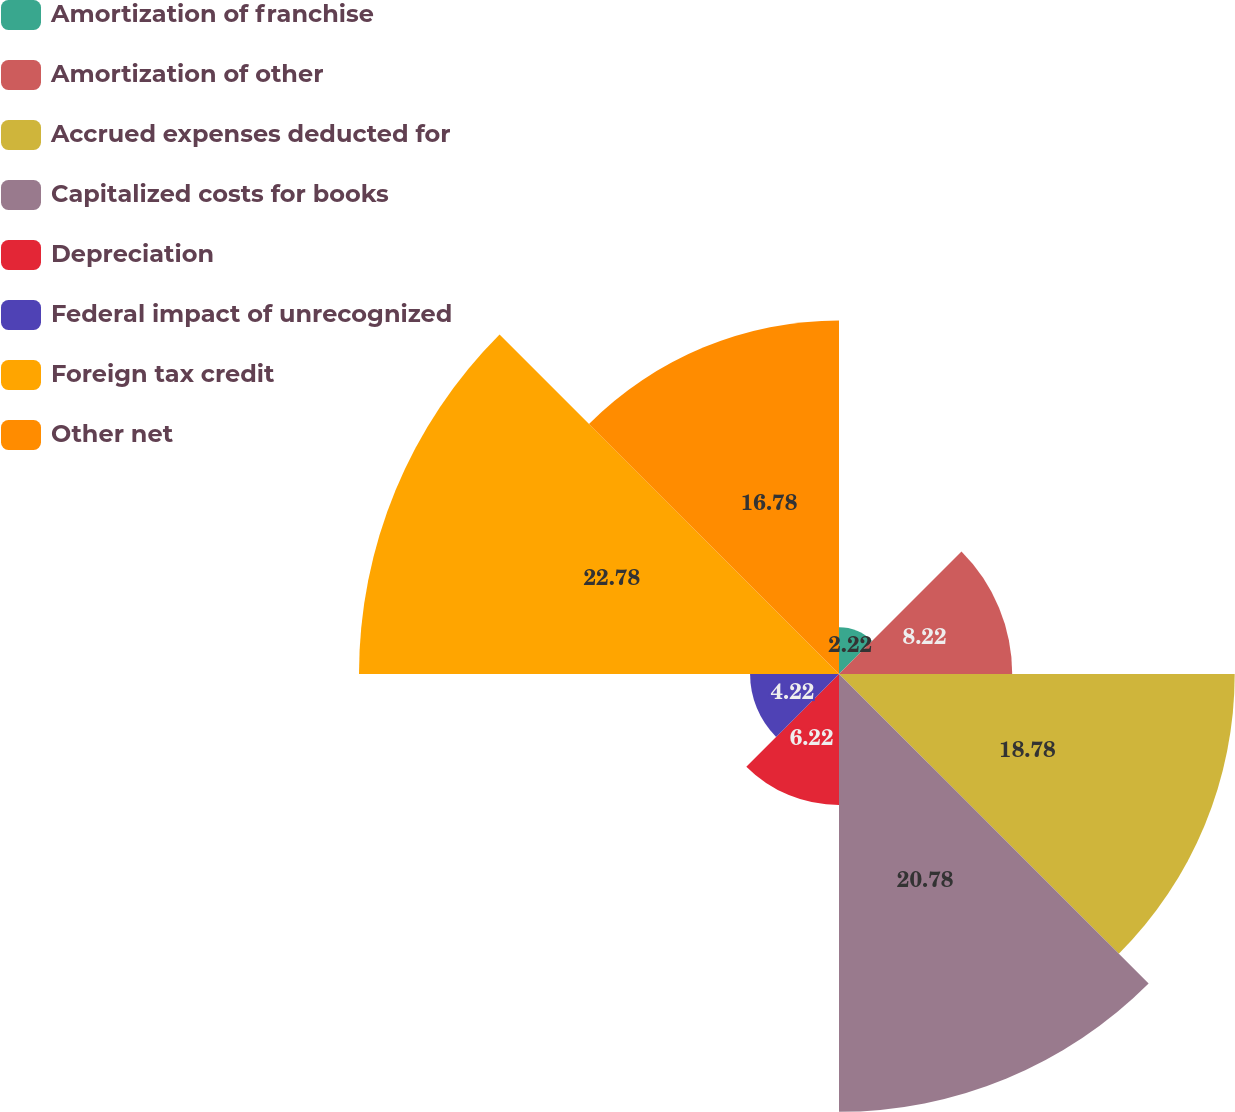Convert chart to OTSL. <chart><loc_0><loc_0><loc_500><loc_500><pie_chart><fcel>Amortization of franchise<fcel>Amortization of other<fcel>Accrued expenses deducted for<fcel>Capitalized costs for books<fcel>Depreciation<fcel>Federal impact of unrecognized<fcel>Foreign tax credit<fcel>Other net<nl><fcel>2.22%<fcel>8.22%<fcel>18.78%<fcel>20.78%<fcel>6.22%<fcel>4.22%<fcel>22.78%<fcel>16.78%<nl></chart> 